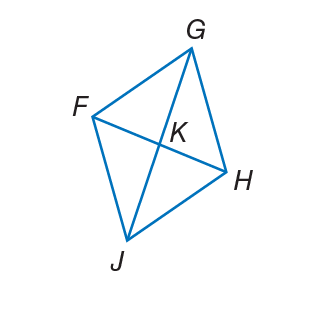Answer the mathemtical geometry problem and directly provide the correct option letter.
Question: The diagonals of rhombus F G H J intersect at K. If m \angle F J H = 82, find m \angle K H J.
Choices: A: 15 B: 33 C: 49 D: 82 C 